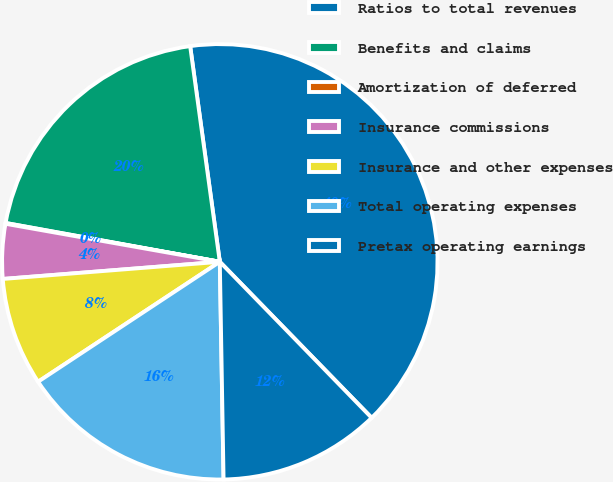Convert chart to OTSL. <chart><loc_0><loc_0><loc_500><loc_500><pie_chart><fcel>Ratios to total revenues<fcel>Benefits and claims<fcel>Amortization of deferred<fcel>Insurance commissions<fcel>Insurance and other expenses<fcel>Total operating expenses<fcel>Pretax operating earnings<nl><fcel>39.89%<fcel>19.97%<fcel>0.06%<fcel>4.05%<fcel>8.03%<fcel>15.99%<fcel>12.01%<nl></chart> 